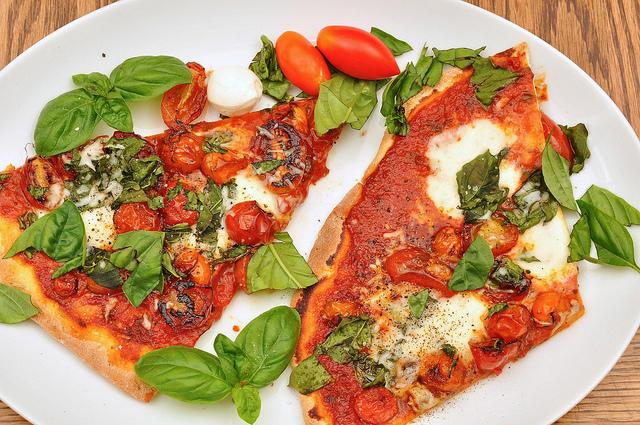What food is this?
Keep it brief. Pizza. What kind of green garnish is on the plate?
Concise answer only. Basil. How many slices are there?
Concise answer only. 2. 